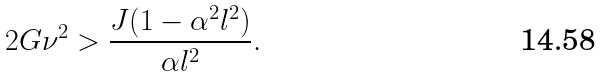Convert formula to latex. <formula><loc_0><loc_0><loc_500><loc_500>2 G \nu ^ { 2 } > \frac { J ( 1 - \alpha ^ { 2 } l ^ { 2 } ) } { \alpha l ^ { 2 } } .</formula> 